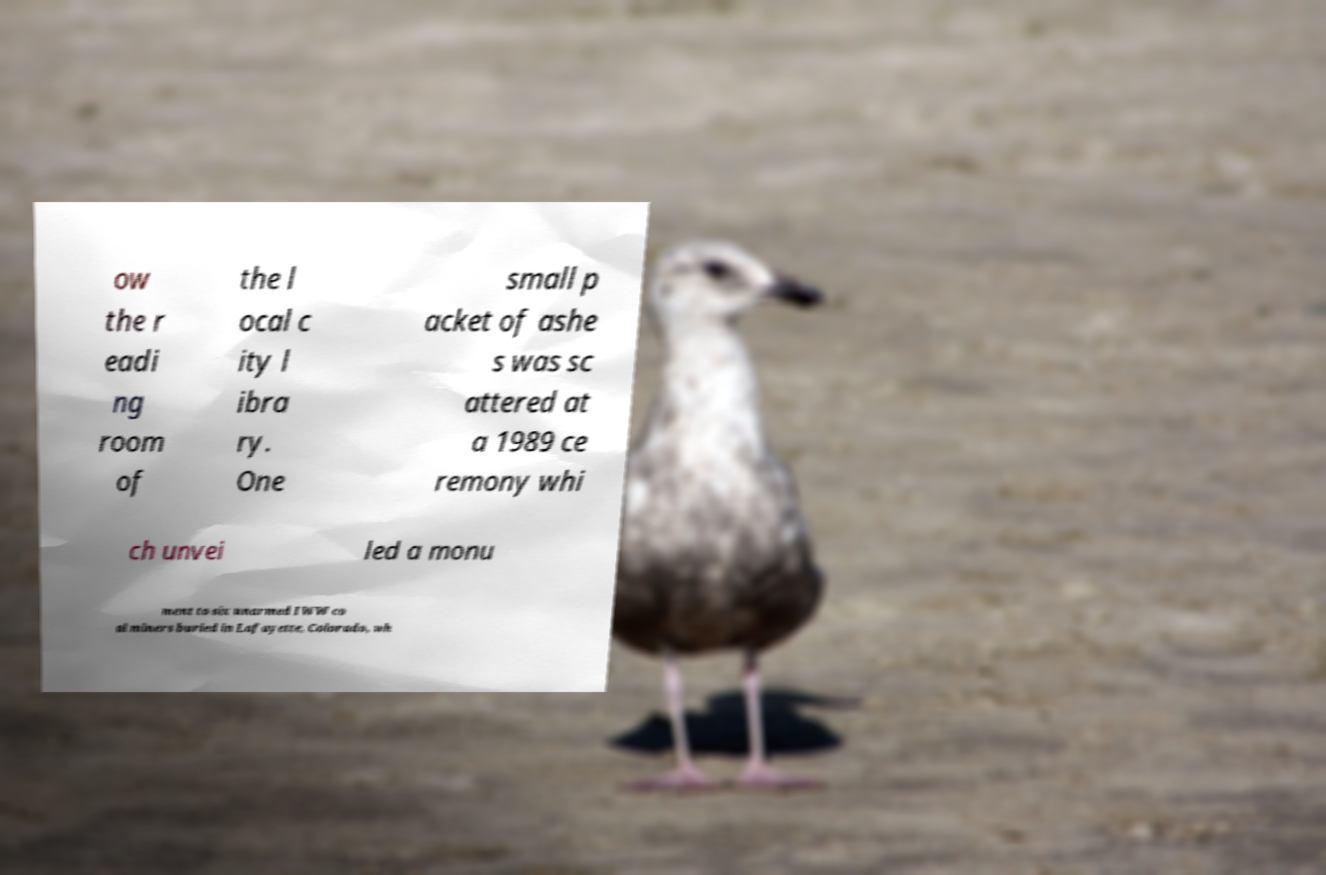Please identify and transcribe the text found in this image. ow the r eadi ng room of the l ocal c ity l ibra ry. One small p acket of ashe s was sc attered at a 1989 ce remony whi ch unvei led a monu ment to six unarmed IWW co al miners buried in Lafayette, Colorado, wh 